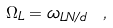<formula> <loc_0><loc_0><loc_500><loc_500>\Omega _ { L } = \omega _ { L N / d } \ ,</formula> 